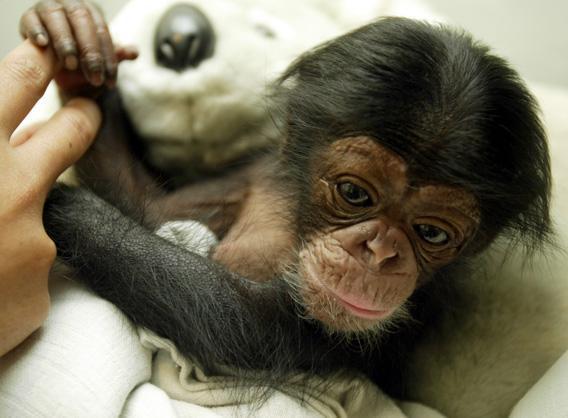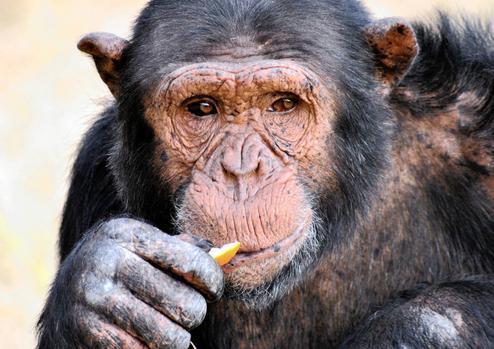The first image is the image on the left, the second image is the image on the right. Assess this claim about the two images: "In one image of each pair two chimpanzees are hugging.". Correct or not? Answer yes or no. No. 